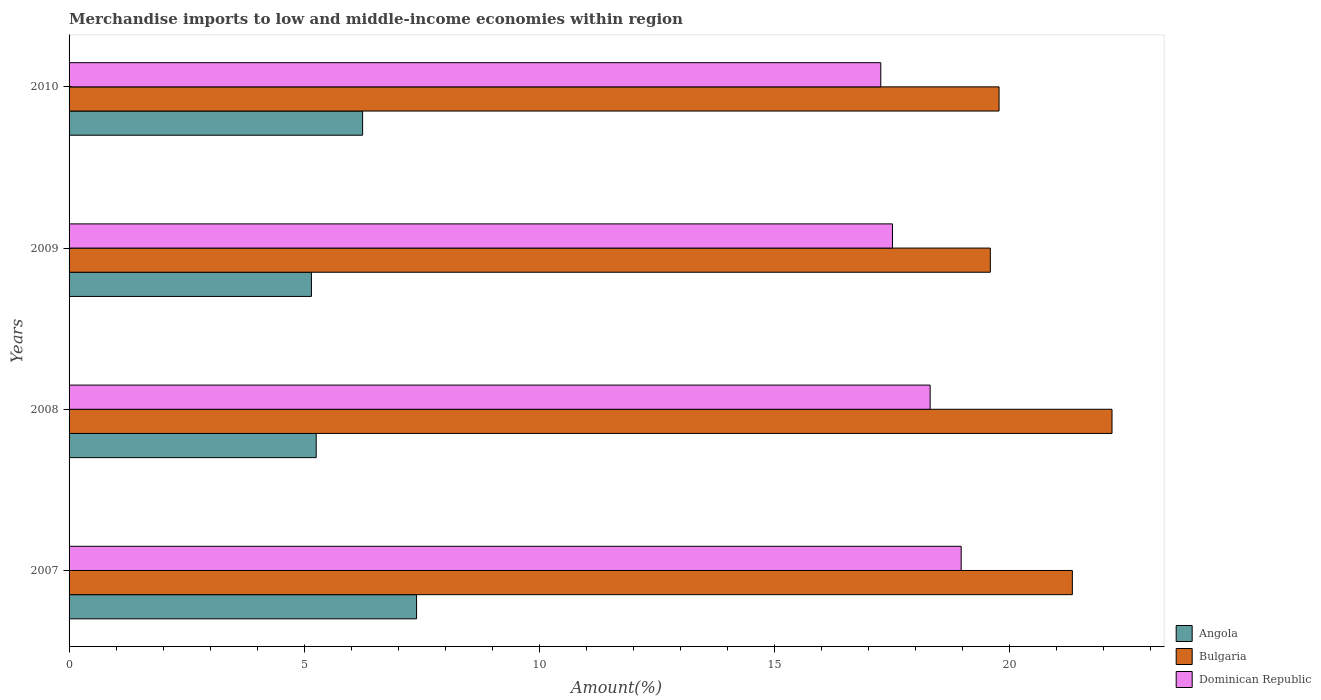Are the number of bars on each tick of the Y-axis equal?
Offer a terse response. Yes. How many bars are there on the 2nd tick from the top?
Ensure brevity in your answer.  3. How many bars are there on the 4th tick from the bottom?
Offer a terse response. 3. In how many cases, is the number of bars for a given year not equal to the number of legend labels?
Provide a succinct answer. 0. What is the percentage of amount earned from merchandise imports in Bulgaria in 2009?
Keep it short and to the point. 19.59. Across all years, what is the maximum percentage of amount earned from merchandise imports in Dominican Republic?
Keep it short and to the point. 18.97. Across all years, what is the minimum percentage of amount earned from merchandise imports in Angola?
Provide a short and direct response. 5.15. In which year was the percentage of amount earned from merchandise imports in Angola maximum?
Make the answer very short. 2007. What is the total percentage of amount earned from merchandise imports in Bulgaria in the graph?
Provide a short and direct response. 82.89. What is the difference between the percentage of amount earned from merchandise imports in Dominican Republic in 2008 and that in 2010?
Give a very brief answer. 1.05. What is the difference between the percentage of amount earned from merchandise imports in Angola in 2009 and the percentage of amount earned from merchandise imports in Dominican Republic in 2008?
Give a very brief answer. -13.16. What is the average percentage of amount earned from merchandise imports in Dominican Republic per year?
Make the answer very short. 18.01. In the year 2009, what is the difference between the percentage of amount earned from merchandise imports in Bulgaria and percentage of amount earned from merchandise imports in Angola?
Your answer should be very brief. 14.44. In how many years, is the percentage of amount earned from merchandise imports in Angola greater than 20 %?
Offer a very short reply. 0. What is the ratio of the percentage of amount earned from merchandise imports in Dominican Republic in 2007 to that in 2009?
Offer a very short reply. 1.08. Is the percentage of amount earned from merchandise imports in Angola in 2008 less than that in 2010?
Provide a short and direct response. Yes. Is the difference between the percentage of amount earned from merchandise imports in Bulgaria in 2007 and 2008 greater than the difference between the percentage of amount earned from merchandise imports in Angola in 2007 and 2008?
Your answer should be very brief. No. What is the difference between the highest and the second highest percentage of amount earned from merchandise imports in Dominican Republic?
Your answer should be compact. 0.66. What is the difference between the highest and the lowest percentage of amount earned from merchandise imports in Bulgaria?
Make the answer very short. 2.59. What does the 3rd bar from the top in 2008 represents?
Ensure brevity in your answer.  Angola. What does the 3rd bar from the bottom in 2008 represents?
Make the answer very short. Dominican Republic. Is it the case that in every year, the sum of the percentage of amount earned from merchandise imports in Bulgaria and percentage of amount earned from merchandise imports in Angola is greater than the percentage of amount earned from merchandise imports in Dominican Republic?
Provide a short and direct response. Yes. Are all the bars in the graph horizontal?
Keep it short and to the point. Yes. What is the difference between two consecutive major ticks on the X-axis?
Your answer should be compact. 5. Are the values on the major ticks of X-axis written in scientific E-notation?
Offer a terse response. No. Does the graph contain any zero values?
Give a very brief answer. No. Where does the legend appear in the graph?
Your answer should be compact. Bottom right. How many legend labels are there?
Keep it short and to the point. 3. How are the legend labels stacked?
Ensure brevity in your answer.  Vertical. What is the title of the graph?
Keep it short and to the point. Merchandise imports to low and middle-income economies within region. Does "Costa Rica" appear as one of the legend labels in the graph?
Keep it short and to the point. No. What is the label or title of the X-axis?
Give a very brief answer. Amount(%). What is the label or title of the Y-axis?
Keep it short and to the point. Years. What is the Amount(%) of Angola in 2007?
Offer a very short reply. 7.39. What is the Amount(%) in Bulgaria in 2007?
Offer a terse response. 21.34. What is the Amount(%) in Dominican Republic in 2007?
Offer a very short reply. 18.97. What is the Amount(%) of Angola in 2008?
Make the answer very short. 5.26. What is the Amount(%) of Bulgaria in 2008?
Provide a short and direct response. 22.18. What is the Amount(%) of Dominican Republic in 2008?
Make the answer very short. 18.31. What is the Amount(%) of Angola in 2009?
Ensure brevity in your answer.  5.15. What is the Amount(%) of Bulgaria in 2009?
Offer a very short reply. 19.59. What is the Amount(%) in Dominican Republic in 2009?
Give a very brief answer. 17.51. What is the Amount(%) of Angola in 2010?
Offer a very short reply. 6.24. What is the Amount(%) of Bulgaria in 2010?
Provide a short and direct response. 19.78. What is the Amount(%) of Dominican Republic in 2010?
Give a very brief answer. 17.26. Across all years, what is the maximum Amount(%) in Angola?
Provide a succinct answer. 7.39. Across all years, what is the maximum Amount(%) in Bulgaria?
Offer a terse response. 22.18. Across all years, what is the maximum Amount(%) in Dominican Republic?
Offer a terse response. 18.97. Across all years, what is the minimum Amount(%) of Angola?
Provide a succinct answer. 5.15. Across all years, what is the minimum Amount(%) in Bulgaria?
Your answer should be very brief. 19.59. Across all years, what is the minimum Amount(%) in Dominican Republic?
Your answer should be very brief. 17.26. What is the total Amount(%) of Angola in the graph?
Give a very brief answer. 24.04. What is the total Amount(%) of Bulgaria in the graph?
Offer a terse response. 82.89. What is the total Amount(%) of Dominican Republic in the graph?
Ensure brevity in your answer.  72.06. What is the difference between the Amount(%) in Angola in 2007 and that in 2008?
Ensure brevity in your answer.  2.13. What is the difference between the Amount(%) of Bulgaria in 2007 and that in 2008?
Your answer should be very brief. -0.84. What is the difference between the Amount(%) of Dominican Republic in 2007 and that in 2008?
Offer a very short reply. 0.66. What is the difference between the Amount(%) in Angola in 2007 and that in 2009?
Make the answer very short. 2.24. What is the difference between the Amount(%) in Bulgaria in 2007 and that in 2009?
Your answer should be very brief. 1.74. What is the difference between the Amount(%) in Dominican Republic in 2007 and that in 2009?
Ensure brevity in your answer.  1.46. What is the difference between the Amount(%) of Angola in 2007 and that in 2010?
Provide a succinct answer. 1.15. What is the difference between the Amount(%) in Bulgaria in 2007 and that in 2010?
Your answer should be very brief. 1.56. What is the difference between the Amount(%) in Dominican Republic in 2007 and that in 2010?
Your response must be concise. 1.71. What is the difference between the Amount(%) in Angola in 2008 and that in 2009?
Give a very brief answer. 0.1. What is the difference between the Amount(%) of Bulgaria in 2008 and that in 2009?
Your response must be concise. 2.59. What is the difference between the Amount(%) in Dominican Republic in 2008 and that in 2009?
Your answer should be compact. 0.8. What is the difference between the Amount(%) in Angola in 2008 and that in 2010?
Your answer should be compact. -0.99. What is the difference between the Amount(%) of Bulgaria in 2008 and that in 2010?
Your answer should be compact. 2.4. What is the difference between the Amount(%) of Dominican Republic in 2008 and that in 2010?
Offer a terse response. 1.05. What is the difference between the Amount(%) in Angola in 2009 and that in 2010?
Provide a succinct answer. -1.09. What is the difference between the Amount(%) in Bulgaria in 2009 and that in 2010?
Your answer should be compact. -0.19. What is the difference between the Amount(%) in Dominican Republic in 2009 and that in 2010?
Ensure brevity in your answer.  0.25. What is the difference between the Amount(%) of Angola in 2007 and the Amount(%) of Bulgaria in 2008?
Make the answer very short. -14.79. What is the difference between the Amount(%) of Angola in 2007 and the Amount(%) of Dominican Republic in 2008?
Make the answer very short. -10.92. What is the difference between the Amount(%) of Bulgaria in 2007 and the Amount(%) of Dominican Republic in 2008?
Provide a succinct answer. 3.02. What is the difference between the Amount(%) of Angola in 2007 and the Amount(%) of Bulgaria in 2009?
Ensure brevity in your answer.  -12.2. What is the difference between the Amount(%) of Angola in 2007 and the Amount(%) of Dominican Republic in 2009?
Your answer should be compact. -10.12. What is the difference between the Amount(%) in Bulgaria in 2007 and the Amount(%) in Dominican Republic in 2009?
Make the answer very short. 3.83. What is the difference between the Amount(%) of Angola in 2007 and the Amount(%) of Bulgaria in 2010?
Your answer should be compact. -12.39. What is the difference between the Amount(%) of Angola in 2007 and the Amount(%) of Dominican Republic in 2010?
Your response must be concise. -9.87. What is the difference between the Amount(%) in Bulgaria in 2007 and the Amount(%) in Dominican Republic in 2010?
Provide a succinct answer. 4.07. What is the difference between the Amount(%) in Angola in 2008 and the Amount(%) in Bulgaria in 2009?
Ensure brevity in your answer.  -14.34. What is the difference between the Amount(%) in Angola in 2008 and the Amount(%) in Dominican Republic in 2009?
Your response must be concise. -12.26. What is the difference between the Amount(%) in Bulgaria in 2008 and the Amount(%) in Dominican Republic in 2009?
Your answer should be very brief. 4.67. What is the difference between the Amount(%) in Angola in 2008 and the Amount(%) in Bulgaria in 2010?
Keep it short and to the point. -14.52. What is the difference between the Amount(%) of Angola in 2008 and the Amount(%) of Dominican Republic in 2010?
Give a very brief answer. -12.01. What is the difference between the Amount(%) of Bulgaria in 2008 and the Amount(%) of Dominican Republic in 2010?
Keep it short and to the point. 4.92. What is the difference between the Amount(%) of Angola in 2009 and the Amount(%) of Bulgaria in 2010?
Ensure brevity in your answer.  -14.62. What is the difference between the Amount(%) of Angola in 2009 and the Amount(%) of Dominican Republic in 2010?
Offer a very short reply. -12.11. What is the difference between the Amount(%) of Bulgaria in 2009 and the Amount(%) of Dominican Republic in 2010?
Ensure brevity in your answer.  2.33. What is the average Amount(%) of Angola per year?
Provide a short and direct response. 6.01. What is the average Amount(%) of Bulgaria per year?
Keep it short and to the point. 20.72. What is the average Amount(%) in Dominican Republic per year?
Your response must be concise. 18.01. In the year 2007, what is the difference between the Amount(%) of Angola and Amount(%) of Bulgaria?
Give a very brief answer. -13.95. In the year 2007, what is the difference between the Amount(%) in Angola and Amount(%) in Dominican Republic?
Ensure brevity in your answer.  -11.58. In the year 2007, what is the difference between the Amount(%) in Bulgaria and Amount(%) in Dominican Republic?
Provide a succinct answer. 2.36. In the year 2008, what is the difference between the Amount(%) in Angola and Amount(%) in Bulgaria?
Provide a succinct answer. -16.92. In the year 2008, what is the difference between the Amount(%) in Angola and Amount(%) in Dominican Republic?
Offer a very short reply. -13.06. In the year 2008, what is the difference between the Amount(%) in Bulgaria and Amount(%) in Dominican Republic?
Your answer should be compact. 3.87. In the year 2009, what is the difference between the Amount(%) in Angola and Amount(%) in Bulgaria?
Make the answer very short. -14.44. In the year 2009, what is the difference between the Amount(%) in Angola and Amount(%) in Dominican Republic?
Your response must be concise. -12.36. In the year 2009, what is the difference between the Amount(%) in Bulgaria and Amount(%) in Dominican Republic?
Offer a terse response. 2.08. In the year 2010, what is the difference between the Amount(%) of Angola and Amount(%) of Bulgaria?
Keep it short and to the point. -13.54. In the year 2010, what is the difference between the Amount(%) in Angola and Amount(%) in Dominican Republic?
Your response must be concise. -11.02. In the year 2010, what is the difference between the Amount(%) of Bulgaria and Amount(%) of Dominican Republic?
Provide a succinct answer. 2.52. What is the ratio of the Amount(%) of Angola in 2007 to that in 2008?
Give a very brief answer. 1.41. What is the ratio of the Amount(%) in Dominican Republic in 2007 to that in 2008?
Your response must be concise. 1.04. What is the ratio of the Amount(%) in Angola in 2007 to that in 2009?
Provide a succinct answer. 1.43. What is the ratio of the Amount(%) of Bulgaria in 2007 to that in 2009?
Keep it short and to the point. 1.09. What is the ratio of the Amount(%) in Dominican Republic in 2007 to that in 2009?
Make the answer very short. 1.08. What is the ratio of the Amount(%) of Angola in 2007 to that in 2010?
Keep it short and to the point. 1.18. What is the ratio of the Amount(%) of Bulgaria in 2007 to that in 2010?
Give a very brief answer. 1.08. What is the ratio of the Amount(%) in Dominican Republic in 2007 to that in 2010?
Offer a terse response. 1.1. What is the ratio of the Amount(%) in Angola in 2008 to that in 2009?
Your answer should be very brief. 1.02. What is the ratio of the Amount(%) of Bulgaria in 2008 to that in 2009?
Your answer should be very brief. 1.13. What is the ratio of the Amount(%) of Dominican Republic in 2008 to that in 2009?
Ensure brevity in your answer.  1.05. What is the ratio of the Amount(%) of Angola in 2008 to that in 2010?
Keep it short and to the point. 0.84. What is the ratio of the Amount(%) in Bulgaria in 2008 to that in 2010?
Your answer should be compact. 1.12. What is the ratio of the Amount(%) of Dominican Republic in 2008 to that in 2010?
Your response must be concise. 1.06. What is the ratio of the Amount(%) in Angola in 2009 to that in 2010?
Your answer should be compact. 0.83. What is the ratio of the Amount(%) in Bulgaria in 2009 to that in 2010?
Keep it short and to the point. 0.99. What is the ratio of the Amount(%) in Dominican Republic in 2009 to that in 2010?
Your answer should be very brief. 1.01. What is the difference between the highest and the second highest Amount(%) of Angola?
Give a very brief answer. 1.15. What is the difference between the highest and the second highest Amount(%) in Bulgaria?
Your answer should be compact. 0.84. What is the difference between the highest and the second highest Amount(%) of Dominican Republic?
Make the answer very short. 0.66. What is the difference between the highest and the lowest Amount(%) of Angola?
Provide a succinct answer. 2.24. What is the difference between the highest and the lowest Amount(%) in Bulgaria?
Offer a very short reply. 2.59. What is the difference between the highest and the lowest Amount(%) in Dominican Republic?
Ensure brevity in your answer.  1.71. 